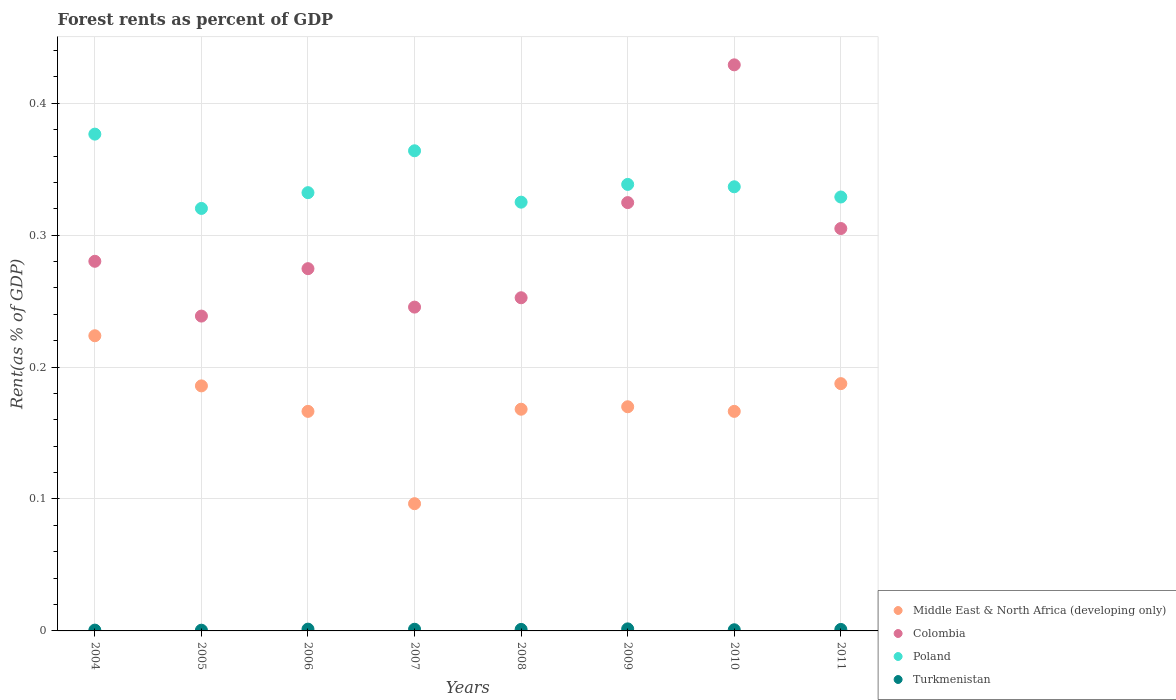What is the forest rent in Middle East & North Africa (developing only) in 2010?
Offer a very short reply. 0.17. Across all years, what is the maximum forest rent in Colombia?
Offer a very short reply. 0.43. Across all years, what is the minimum forest rent in Middle East & North Africa (developing only)?
Your answer should be compact. 0.1. In which year was the forest rent in Turkmenistan maximum?
Ensure brevity in your answer.  2009. What is the total forest rent in Colombia in the graph?
Your answer should be compact. 2.35. What is the difference between the forest rent in Colombia in 2010 and that in 2011?
Your answer should be compact. 0.12. What is the difference between the forest rent in Turkmenistan in 2008 and the forest rent in Colombia in 2007?
Your answer should be very brief. -0.24. What is the average forest rent in Turkmenistan per year?
Your answer should be very brief. 0. In the year 2007, what is the difference between the forest rent in Turkmenistan and forest rent in Poland?
Your response must be concise. -0.36. What is the ratio of the forest rent in Poland in 2005 to that in 2008?
Your response must be concise. 0.99. Is the forest rent in Turkmenistan in 2010 less than that in 2011?
Provide a short and direct response. Yes. What is the difference between the highest and the second highest forest rent in Poland?
Your answer should be very brief. 0.01. What is the difference between the highest and the lowest forest rent in Middle East & North Africa (developing only)?
Give a very brief answer. 0.13. In how many years, is the forest rent in Middle East & North Africa (developing only) greater than the average forest rent in Middle East & North Africa (developing only) taken over all years?
Make the answer very short. 3. Is the sum of the forest rent in Turkmenistan in 2007 and 2009 greater than the maximum forest rent in Poland across all years?
Give a very brief answer. No. Is it the case that in every year, the sum of the forest rent in Turkmenistan and forest rent in Colombia  is greater than the sum of forest rent in Middle East & North Africa (developing only) and forest rent in Poland?
Your answer should be compact. No. Does the forest rent in Poland monotonically increase over the years?
Provide a short and direct response. No. Is the forest rent in Colombia strictly greater than the forest rent in Middle East & North Africa (developing only) over the years?
Keep it short and to the point. Yes. How many years are there in the graph?
Provide a succinct answer. 8. Are the values on the major ticks of Y-axis written in scientific E-notation?
Provide a succinct answer. No. Does the graph contain any zero values?
Offer a very short reply. No. Does the graph contain grids?
Keep it short and to the point. Yes. Where does the legend appear in the graph?
Make the answer very short. Bottom right. How many legend labels are there?
Offer a terse response. 4. What is the title of the graph?
Keep it short and to the point. Forest rents as percent of GDP. Does "Ghana" appear as one of the legend labels in the graph?
Offer a terse response. No. What is the label or title of the Y-axis?
Make the answer very short. Rent(as % of GDP). What is the Rent(as % of GDP) of Middle East & North Africa (developing only) in 2004?
Your answer should be compact. 0.22. What is the Rent(as % of GDP) of Colombia in 2004?
Provide a short and direct response. 0.28. What is the Rent(as % of GDP) of Poland in 2004?
Offer a terse response. 0.38. What is the Rent(as % of GDP) in Turkmenistan in 2004?
Your answer should be very brief. 0. What is the Rent(as % of GDP) in Middle East & North Africa (developing only) in 2005?
Offer a terse response. 0.19. What is the Rent(as % of GDP) of Colombia in 2005?
Your answer should be compact. 0.24. What is the Rent(as % of GDP) of Poland in 2005?
Keep it short and to the point. 0.32. What is the Rent(as % of GDP) of Turkmenistan in 2005?
Provide a short and direct response. 0. What is the Rent(as % of GDP) in Middle East & North Africa (developing only) in 2006?
Offer a terse response. 0.17. What is the Rent(as % of GDP) of Colombia in 2006?
Provide a succinct answer. 0.27. What is the Rent(as % of GDP) in Poland in 2006?
Give a very brief answer. 0.33. What is the Rent(as % of GDP) in Turkmenistan in 2006?
Make the answer very short. 0. What is the Rent(as % of GDP) in Middle East & North Africa (developing only) in 2007?
Offer a very short reply. 0.1. What is the Rent(as % of GDP) in Colombia in 2007?
Make the answer very short. 0.25. What is the Rent(as % of GDP) of Poland in 2007?
Offer a very short reply. 0.36. What is the Rent(as % of GDP) in Turkmenistan in 2007?
Keep it short and to the point. 0. What is the Rent(as % of GDP) of Middle East & North Africa (developing only) in 2008?
Ensure brevity in your answer.  0.17. What is the Rent(as % of GDP) in Colombia in 2008?
Offer a terse response. 0.25. What is the Rent(as % of GDP) of Poland in 2008?
Your answer should be compact. 0.33. What is the Rent(as % of GDP) of Turkmenistan in 2008?
Ensure brevity in your answer.  0. What is the Rent(as % of GDP) of Middle East & North Africa (developing only) in 2009?
Ensure brevity in your answer.  0.17. What is the Rent(as % of GDP) of Colombia in 2009?
Provide a succinct answer. 0.32. What is the Rent(as % of GDP) of Poland in 2009?
Provide a succinct answer. 0.34. What is the Rent(as % of GDP) in Turkmenistan in 2009?
Your answer should be compact. 0. What is the Rent(as % of GDP) of Middle East & North Africa (developing only) in 2010?
Give a very brief answer. 0.17. What is the Rent(as % of GDP) of Colombia in 2010?
Your response must be concise. 0.43. What is the Rent(as % of GDP) of Poland in 2010?
Provide a short and direct response. 0.34. What is the Rent(as % of GDP) in Turkmenistan in 2010?
Give a very brief answer. 0. What is the Rent(as % of GDP) of Middle East & North Africa (developing only) in 2011?
Your response must be concise. 0.19. What is the Rent(as % of GDP) in Colombia in 2011?
Provide a short and direct response. 0.31. What is the Rent(as % of GDP) of Poland in 2011?
Ensure brevity in your answer.  0.33. What is the Rent(as % of GDP) of Turkmenistan in 2011?
Keep it short and to the point. 0. Across all years, what is the maximum Rent(as % of GDP) in Middle East & North Africa (developing only)?
Your response must be concise. 0.22. Across all years, what is the maximum Rent(as % of GDP) of Colombia?
Offer a very short reply. 0.43. Across all years, what is the maximum Rent(as % of GDP) of Poland?
Offer a terse response. 0.38. Across all years, what is the maximum Rent(as % of GDP) in Turkmenistan?
Keep it short and to the point. 0. Across all years, what is the minimum Rent(as % of GDP) in Middle East & North Africa (developing only)?
Keep it short and to the point. 0.1. Across all years, what is the minimum Rent(as % of GDP) in Colombia?
Your response must be concise. 0.24. Across all years, what is the minimum Rent(as % of GDP) of Poland?
Provide a short and direct response. 0.32. Across all years, what is the minimum Rent(as % of GDP) in Turkmenistan?
Your answer should be very brief. 0. What is the total Rent(as % of GDP) of Middle East & North Africa (developing only) in the graph?
Provide a short and direct response. 1.36. What is the total Rent(as % of GDP) in Colombia in the graph?
Your response must be concise. 2.35. What is the total Rent(as % of GDP) in Poland in the graph?
Provide a short and direct response. 2.72. What is the total Rent(as % of GDP) in Turkmenistan in the graph?
Offer a very short reply. 0.01. What is the difference between the Rent(as % of GDP) of Middle East & North Africa (developing only) in 2004 and that in 2005?
Give a very brief answer. 0.04. What is the difference between the Rent(as % of GDP) in Colombia in 2004 and that in 2005?
Provide a short and direct response. 0.04. What is the difference between the Rent(as % of GDP) of Poland in 2004 and that in 2005?
Your response must be concise. 0.06. What is the difference between the Rent(as % of GDP) in Turkmenistan in 2004 and that in 2005?
Provide a succinct answer. 0. What is the difference between the Rent(as % of GDP) of Middle East & North Africa (developing only) in 2004 and that in 2006?
Make the answer very short. 0.06. What is the difference between the Rent(as % of GDP) of Colombia in 2004 and that in 2006?
Your answer should be very brief. 0.01. What is the difference between the Rent(as % of GDP) of Poland in 2004 and that in 2006?
Offer a terse response. 0.04. What is the difference between the Rent(as % of GDP) of Turkmenistan in 2004 and that in 2006?
Keep it short and to the point. -0. What is the difference between the Rent(as % of GDP) of Middle East & North Africa (developing only) in 2004 and that in 2007?
Provide a short and direct response. 0.13. What is the difference between the Rent(as % of GDP) of Colombia in 2004 and that in 2007?
Offer a terse response. 0.03. What is the difference between the Rent(as % of GDP) of Poland in 2004 and that in 2007?
Offer a terse response. 0.01. What is the difference between the Rent(as % of GDP) in Turkmenistan in 2004 and that in 2007?
Offer a terse response. -0. What is the difference between the Rent(as % of GDP) of Middle East & North Africa (developing only) in 2004 and that in 2008?
Provide a succinct answer. 0.06. What is the difference between the Rent(as % of GDP) of Colombia in 2004 and that in 2008?
Make the answer very short. 0.03. What is the difference between the Rent(as % of GDP) of Poland in 2004 and that in 2008?
Your answer should be very brief. 0.05. What is the difference between the Rent(as % of GDP) in Turkmenistan in 2004 and that in 2008?
Your answer should be very brief. -0. What is the difference between the Rent(as % of GDP) of Middle East & North Africa (developing only) in 2004 and that in 2009?
Give a very brief answer. 0.05. What is the difference between the Rent(as % of GDP) of Colombia in 2004 and that in 2009?
Make the answer very short. -0.04. What is the difference between the Rent(as % of GDP) of Poland in 2004 and that in 2009?
Keep it short and to the point. 0.04. What is the difference between the Rent(as % of GDP) of Turkmenistan in 2004 and that in 2009?
Keep it short and to the point. -0. What is the difference between the Rent(as % of GDP) of Middle East & North Africa (developing only) in 2004 and that in 2010?
Your answer should be very brief. 0.06. What is the difference between the Rent(as % of GDP) in Colombia in 2004 and that in 2010?
Offer a very short reply. -0.15. What is the difference between the Rent(as % of GDP) in Poland in 2004 and that in 2010?
Your response must be concise. 0.04. What is the difference between the Rent(as % of GDP) of Turkmenistan in 2004 and that in 2010?
Provide a succinct answer. -0. What is the difference between the Rent(as % of GDP) in Middle East & North Africa (developing only) in 2004 and that in 2011?
Your answer should be compact. 0.04. What is the difference between the Rent(as % of GDP) of Colombia in 2004 and that in 2011?
Offer a terse response. -0.02. What is the difference between the Rent(as % of GDP) of Poland in 2004 and that in 2011?
Provide a succinct answer. 0.05. What is the difference between the Rent(as % of GDP) in Turkmenistan in 2004 and that in 2011?
Ensure brevity in your answer.  -0. What is the difference between the Rent(as % of GDP) of Middle East & North Africa (developing only) in 2005 and that in 2006?
Your answer should be very brief. 0.02. What is the difference between the Rent(as % of GDP) in Colombia in 2005 and that in 2006?
Provide a succinct answer. -0.04. What is the difference between the Rent(as % of GDP) of Poland in 2005 and that in 2006?
Your answer should be very brief. -0.01. What is the difference between the Rent(as % of GDP) in Turkmenistan in 2005 and that in 2006?
Ensure brevity in your answer.  -0. What is the difference between the Rent(as % of GDP) in Middle East & North Africa (developing only) in 2005 and that in 2007?
Ensure brevity in your answer.  0.09. What is the difference between the Rent(as % of GDP) of Colombia in 2005 and that in 2007?
Make the answer very short. -0.01. What is the difference between the Rent(as % of GDP) in Poland in 2005 and that in 2007?
Your answer should be compact. -0.04. What is the difference between the Rent(as % of GDP) of Turkmenistan in 2005 and that in 2007?
Keep it short and to the point. -0. What is the difference between the Rent(as % of GDP) in Middle East & North Africa (developing only) in 2005 and that in 2008?
Ensure brevity in your answer.  0.02. What is the difference between the Rent(as % of GDP) of Colombia in 2005 and that in 2008?
Offer a terse response. -0.01. What is the difference between the Rent(as % of GDP) of Poland in 2005 and that in 2008?
Offer a very short reply. -0. What is the difference between the Rent(as % of GDP) of Turkmenistan in 2005 and that in 2008?
Keep it short and to the point. -0. What is the difference between the Rent(as % of GDP) in Middle East & North Africa (developing only) in 2005 and that in 2009?
Ensure brevity in your answer.  0.02. What is the difference between the Rent(as % of GDP) in Colombia in 2005 and that in 2009?
Your response must be concise. -0.09. What is the difference between the Rent(as % of GDP) of Poland in 2005 and that in 2009?
Offer a very short reply. -0.02. What is the difference between the Rent(as % of GDP) in Turkmenistan in 2005 and that in 2009?
Offer a terse response. -0. What is the difference between the Rent(as % of GDP) of Middle East & North Africa (developing only) in 2005 and that in 2010?
Offer a terse response. 0.02. What is the difference between the Rent(as % of GDP) in Colombia in 2005 and that in 2010?
Offer a terse response. -0.19. What is the difference between the Rent(as % of GDP) of Poland in 2005 and that in 2010?
Keep it short and to the point. -0.02. What is the difference between the Rent(as % of GDP) of Turkmenistan in 2005 and that in 2010?
Give a very brief answer. -0. What is the difference between the Rent(as % of GDP) in Middle East & North Africa (developing only) in 2005 and that in 2011?
Provide a succinct answer. -0. What is the difference between the Rent(as % of GDP) of Colombia in 2005 and that in 2011?
Give a very brief answer. -0.07. What is the difference between the Rent(as % of GDP) in Poland in 2005 and that in 2011?
Give a very brief answer. -0.01. What is the difference between the Rent(as % of GDP) in Turkmenistan in 2005 and that in 2011?
Offer a very short reply. -0. What is the difference between the Rent(as % of GDP) in Middle East & North Africa (developing only) in 2006 and that in 2007?
Give a very brief answer. 0.07. What is the difference between the Rent(as % of GDP) of Colombia in 2006 and that in 2007?
Ensure brevity in your answer.  0.03. What is the difference between the Rent(as % of GDP) in Poland in 2006 and that in 2007?
Your answer should be very brief. -0.03. What is the difference between the Rent(as % of GDP) of Middle East & North Africa (developing only) in 2006 and that in 2008?
Offer a terse response. -0. What is the difference between the Rent(as % of GDP) in Colombia in 2006 and that in 2008?
Your response must be concise. 0.02. What is the difference between the Rent(as % of GDP) of Poland in 2006 and that in 2008?
Your response must be concise. 0.01. What is the difference between the Rent(as % of GDP) in Turkmenistan in 2006 and that in 2008?
Offer a very short reply. 0. What is the difference between the Rent(as % of GDP) in Middle East & North Africa (developing only) in 2006 and that in 2009?
Give a very brief answer. -0. What is the difference between the Rent(as % of GDP) of Colombia in 2006 and that in 2009?
Make the answer very short. -0.05. What is the difference between the Rent(as % of GDP) of Poland in 2006 and that in 2009?
Your response must be concise. -0.01. What is the difference between the Rent(as % of GDP) in Turkmenistan in 2006 and that in 2009?
Ensure brevity in your answer.  -0. What is the difference between the Rent(as % of GDP) in Middle East & North Africa (developing only) in 2006 and that in 2010?
Your answer should be compact. -0. What is the difference between the Rent(as % of GDP) in Colombia in 2006 and that in 2010?
Provide a succinct answer. -0.15. What is the difference between the Rent(as % of GDP) in Poland in 2006 and that in 2010?
Ensure brevity in your answer.  -0. What is the difference between the Rent(as % of GDP) of Turkmenistan in 2006 and that in 2010?
Provide a short and direct response. 0. What is the difference between the Rent(as % of GDP) of Middle East & North Africa (developing only) in 2006 and that in 2011?
Your response must be concise. -0.02. What is the difference between the Rent(as % of GDP) of Colombia in 2006 and that in 2011?
Ensure brevity in your answer.  -0.03. What is the difference between the Rent(as % of GDP) in Poland in 2006 and that in 2011?
Ensure brevity in your answer.  0. What is the difference between the Rent(as % of GDP) of Middle East & North Africa (developing only) in 2007 and that in 2008?
Keep it short and to the point. -0.07. What is the difference between the Rent(as % of GDP) of Colombia in 2007 and that in 2008?
Provide a short and direct response. -0.01. What is the difference between the Rent(as % of GDP) in Poland in 2007 and that in 2008?
Make the answer very short. 0.04. What is the difference between the Rent(as % of GDP) of Turkmenistan in 2007 and that in 2008?
Ensure brevity in your answer.  0. What is the difference between the Rent(as % of GDP) in Middle East & North Africa (developing only) in 2007 and that in 2009?
Offer a terse response. -0.07. What is the difference between the Rent(as % of GDP) of Colombia in 2007 and that in 2009?
Ensure brevity in your answer.  -0.08. What is the difference between the Rent(as % of GDP) of Poland in 2007 and that in 2009?
Your answer should be very brief. 0.03. What is the difference between the Rent(as % of GDP) of Turkmenistan in 2007 and that in 2009?
Your response must be concise. -0. What is the difference between the Rent(as % of GDP) of Middle East & North Africa (developing only) in 2007 and that in 2010?
Provide a short and direct response. -0.07. What is the difference between the Rent(as % of GDP) in Colombia in 2007 and that in 2010?
Make the answer very short. -0.18. What is the difference between the Rent(as % of GDP) of Poland in 2007 and that in 2010?
Your answer should be compact. 0.03. What is the difference between the Rent(as % of GDP) in Middle East & North Africa (developing only) in 2007 and that in 2011?
Make the answer very short. -0.09. What is the difference between the Rent(as % of GDP) in Colombia in 2007 and that in 2011?
Ensure brevity in your answer.  -0.06. What is the difference between the Rent(as % of GDP) in Poland in 2007 and that in 2011?
Give a very brief answer. 0.04. What is the difference between the Rent(as % of GDP) in Turkmenistan in 2007 and that in 2011?
Offer a very short reply. 0. What is the difference between the Rent(as % of GDP) in Middle East & North Africa (developing only) in 2008 and that in 2009?
Offer a terse response. -0. What is the difference between the Rent(as % of GDP) in Colombia in 2008 and that in 2009?
Ensure brevity in your answer.  -0.07. What is the difference between the Rent(as % of GDP) of Poland in 2008 and that in 2009?
Your response must be concise. -0.01. What is the difference between the Rent(as % of GDP) of Turkmenistan in 2008 and that in 2009?
Your response must be concise. -0. What is the difference between the Rent(as % of GDP) in Middle East & North Africa (developing only) in 2008 and that in 2010?
Provide a succinct answer. 0. What is the difference between the Rent(as % of GDP) in Colombia in 2008 and that in 2010?
Give a very brief answer. -0.18. What is the difference between the Rent(as % of GDP) in Poland in 2008 and that in 2010?
Make the answer very short. -0.01. What is the difference between the Rent(as % of GDP) in Turkmenistan in 2008 and that in 2010?
Keep it short and to the point. 0. What is the difference between the Rent(as % of GDP) of Middle East & North Africa (developing only) in 2008 and that in 2011?
Provide a short and direct response. -0.02. What is the difference between the Rent(as % of GDP) of Colombia in 2008 and that in 2011?
Provide a succinct answer. -0.05. What is the difference between the Rent(as % of GDP) of Poland in 2008 and that in 2011?
Make the answer very short. -0. What is the difference between the Rent(as % of GDP) of Middle East & North Africa (developing only) in 2009 and that in 2010?
Your answer should be very brief. 0. What is the difference between the Rent(as % of GDP) in Colombia in 2009 and that in 2010?
Give a very brief answer. -0.1. What is the difference between the Rent(as % of GDP) of Poland in 2009 and that in 2010?
Provide a succinct answer. 0. What is the difference between the Rent(as % of GDP) of Turkmenistan in 2009 and that in 2010?
Keep it short and to the point. 0. What is the difference between the Rent(as % of GDP) in Middle East & North Africa (developing only) in 2009 and that in 2011?
Give a very brief answer. -0.02. What is the difference between the Rent(as % of GDP) in Colombia in 2009 and that in 2011?
Ensure brevity in your answer.  0.02. What is the difference between the Rent(as % of GDP) of Poland in 2009 and that in 2011?
Make the answer very short. 0.01. What is the difference between the Rent(as % of GDP) in Turkmenistan in 2009 and that in 2011?
Your answer should be compact. 0. What is the difference between the Rent(as % of GDP) of Middle East & North Africa (developing only) in 2010 and that in 2011?
Keep it short and to the point. -0.02. What is the difference between the Rent(as % of GDP) of Colombia in 2010 and that in 2011?
Provide a short and direct response. 0.12. What is the difference between the Rent(as % of GDP) of Poland in 2010 and that in 2011?
Your response must be concise. 0.01. What is the difference between the Rent(as % of GDP) in Turkmenistan in 2010 and that in 2011?
Your answer should be very brief. -0. What is the difference between the Rent(as % of GDP) in Middle East & North Africa (developing only) in 2004 and the Rent(as % of GDP) in Colombia in 2005?
Your answer should be compact. -0.01. What is the difference between the Rent(as % of GDP) in Middle East & North Africa (developing only) in 2004 and the Rent(as % of GDP) in Poland in 2005?
Provide a succinct answer. -0.1. What is the difference between the Rent(as % of GDP) of Middle East & North Africa (developing only) in 2004 and the Rent(as % of GDP) of Turkmenistan in 2005?
Ensure brevity in your answer.  0.22. What is the difference between the Rent(as % of GDP) of Colombia in 2004 and the Rent(as % of GDP) of Poland in 2005?
Keep it short and to the point. -0.04. What is the difference between the Rent(as % of GDP) of Colombia in 2004 and the Rent(as % of GDP) of Turkmenistan in 2005?
Keep it short and to the point. 0.28. What is the difference between the Rent(as % of GDP) of Poland in 2004 and the Rent(as % of GDP) of Turkmenistan in 2005?
Keep it short and to the point. 0.38. What is the difference between the Rent(as % of GDP) of Middle East & North Africa (developing only) in 2004 and the Rent(as % of GDP) of Colombia in 2006?
Your response must be concise. -0.05. What is the difference between the Rent(as % of GDP) in Middle East & North Africa (developing only) in 2004 and the Rent(as % of GDP) in Poland in 2006?
Offer a terse response. -0.11. What is the difference between the Rent(as % of GDP) in Middle East & North Africa (developing only) in 2004 and the Rent(as % of GDP) in Turkmenistan in 2006?
Make the answer very short. 0.22. What is the difference between the Rent(as % of GDP) in Colombia in 2004 and the Rent(as % of GDP) in Poland in 2006?
Provide a short and direct response. -0.05. What is the difference between the Rent(as % of GDP) in Colombia in 2004 and the Rent(as % of GDP) in Turkmenistan in 2006?
Give a very brief answer. 0.28. What is the difference between the Rent(as % of GDP) in Poland in 2004 and the Rent(as % of GDP) in Turkmenistan in 2006?
Your response must be concise. 0.38. What is the difference between the Rent(as % of GDP) in Middle East & North Africa (developing only) in 2004 and the Rent(as % of GDP) in Colombia in 2007?
Ensure brevity in your answer.  -0.02. What is the difference between the Rent(as % of GDP) of Middle East & North Africa (developing only) in 2004 and the Rent(as % of GDP) of Poland in 2007?
Provide a short and direct response. -0.14. What is the difference between the Rent(as % of GDP) of Middle East & North Africa (developing only) in 2004 and the Rent(as % of GDP) of Turkmenistan in 2007?
Your response must be concise. 0.22. What is the difference between the Rent(as % of GDP) in Colombia in 2004 and the Rent(as % of GDP) in Poland in 2007?
Make the answer very short. -0.08. What is the difference between the Rent(as % of GDP) in Colombia in 2004 and the Rent(as % of GDP) in Turkmenistan in 2007?
Your answer should be very brief. 0.28. What is the difference between the Rent(as % of GDP) of Poland in 2004 and the Rent(as % of GDP) of Turkmenistan in 2007?
Keep it short and to the point. 0.38. What is the difference between the Rent(as % of GDP) of Middle East & North Africa (developing only) in 2004 and the Rent(as % of GDP) of Colombia in 2008?
Offer a terse response. -0.03. What is the difference between the Rent(as % of GDP) in Middle East & North Africa (developing only) in 2004 and the Rent(as % of GDP) in Poland in 2008?
Offer a very short reply. -0.1. What is the difference between the Rent(as % of GDP) of Middle East & North Africa (developing only) in 2004 and the Rent(as % of GDP) of Turkmenistan in 2008?
Your answer should be compact. 0.22. What is the difference between the Rent(as % of GDP) of Colombia in 2004 and the Rent(as % of GDP) of Poland in 2008?
Offer a terse response. -0.04. What is the difference between the Rent(as % of GDP) in Colombia in 2004 and the Rent(as % of GDP) in Turkmenistan in 2008?
Ensure brevity in your answer.  0.28. What is the difference between the Rent(as % of GDP) in Poland in 2004 and the Rent(as % of GDP) in Turkmenistan in 2008?
Your response must be concise. 0.38. What is the difference between the Rent(as % of GDP) of Middle East & North Africa (developing only) in 2004 and the Rent(as % of GDP) of Colombia in 2009?
Ensure brevity in your answer.  -0.1. What is the difference between the Rent(as % of GDP) of Middle East & North Africa (developing only) in 2004 and the Rent(as % of GDP) of Poland in 2009?
Give a very brief answer. -0.11. What is the difference between the Rent(as % of GDP) of Middle East & North Africa (developing only) in 2004 and the Rent(as % of GDP) of Turkmenistan in 2009?
Give a very brief answer. 0.22. What is the difference between the Rent(as % of GDP) of Colombia in 2004 and the Rent(as % of GDP) of Poland in 2009?
Give a very brief answer. -0.06. What is the difference between the Rent(as % of GDP) in Colombia in 2004 and the Rent(as % of GDP) in Turkmenistan in 2009?
Your response must be concise. 0.28. What is the difference between the Rent(as % of GDP) of Middle East & North Africa (developing only) in 2004 and the Rent(as % of GDP) of Colombia in 2010?
Provide a short and direct response. -0.21. What is the difference between the Rent(as % of GDP) of Middle East & North Africa (developing only) in 2004 and the Rent(as % of GDP) of Poland in 2010?
Provide a succinct answer. -0.11. What is the difference between the Rent(as % of GDP) of Middle East & North Africa (developing only) in 2004 and the Rent(as % of GDP) of Turkmenistan in 2010?
Your response must be concise. 0.22. What is the difference between the Rent(as % of GDP) of Colombia in 2004 and the Rent(as % of GDP) of Poland in 2010?
Offer a terse response. -0.06. What is the difference between the Rent(as % of GDP) of Colombia in 2004 and the Rent(as % of GDP) of Turkmenistan in 2010?
Give a very brief answer. 0.28. What is the difference between the Rent(as % of GDP) in Poland in 2004 and the Rent(as % of GDP) in Turkmenistan in 2010?
Your answer should be compact. 0.38. What is the difference between the Rent(as % of GDP) in Middle East & North Africa (developing only) in 2004 and the Rent(as % of GDP) in Colombia in 2011?
Provide a succinct answer. -0.08. What is the difference between the Rent(as % of GDP) in Middle East & North Africa (developing only) in 2004 and the Rent(as % of GDP) in Poland in 2011?
Ensure brevity in your answer.  -0.11. What is the difference between the Rent(as % of GDP) in Middle East & North Africa (developing only) in 2004 and the Rent(as % of GDP) in Turkmenistan in 2011?
Provide a short and direct response. 0.22. What is the difference between the Rent(as % of GDP) of Colombia in 2004 and the Rent(as % of GDP) of Poland in 2011?
Provide a succinct answer. -0.05. What is the difference between the Rent(as % of GDP) of Colombia in 2004 and the Rent(as % of GDP) of Turkmenistan in 2011?
Your answer should be very brief. 0.28. What is the difference between the Rent(as % of GDP) in Poland in 2004 and the Rent(as % of GDP) in Turkmenistan in 2011?
Offer a very short reply. 0.38. What is the difference between the Rent(as % of GDP) in Middle East & North Africa (developing only) in 2005 and the Rent(as % of GDP) in Colombia in 2006?
Offer a very short reply. -0.09. What is the difference between the Rent(as % of GDP) in Middle East & North Africa (developing only) in 2005 and the Rent(as % of GDP) in Poland in 2006?
Offer a terse response. -0.15. What is the difference between the Rent(as % of GDP) of Middle East & North Africa (developing only) in 2005 and the Rent(as % of GDP) of Turkmenistan in 2006?
Make the answer very short. 0.18. What is the difference between the Rent(as % of GDP) in Colombia in 2005 and the Rent(as % of GDP) in Poland in 2006?
Offer a terse response. -0.09. What is the difference between the Rent(as % of GDP) of Colombia in 2005 and the Rent(as % of GDP) of Turkmenistan in 2006?
Provide a short and direct response. 0.24. What is the difference between the Rent(as % of GDP) in Poland in 2005 and the Rent(as % of GDP) in Turkmenistan in 2006?
Make the answer very short. 0.32. What is the difference between the Rent(as % of GDP) in Middle East & North Africa (developing only) in 2005 and the Rent(as % of GDP) in Colombia in 2007?
Your response must be concise. -0.06. What is the difference between the Rent(as % of GDP) of Middle East & North Africa (developing only) in 2005 and the Rent(as % of GDP) of Poland in 2007?
Provide a short and direct response. -0.18. What is the difference between the Rent(as % of GDP) of Middle East & North Africa (developing only) in 2005 and the Rent(as % of GDP) of Turkmenistan in 2007?
Give a very brief answer. 0.18. What is the difference between the Rent(as % of GDP) in Colombia in 2005 and the Rent(as % of GDP) in Poland in 2007?
Keep it short and to the point. -0.13. What is the difference between the Rent(as % of GDP) in Colombia in 2005 and the Rent(as % of GDP) in Turkmenistan in 2007?
Provide a succinct answer. 0.24. What is the difference between the Rent(as % of GDP) in Poland in 2005 and the Rent(as % of GDP) in Turkmenistan in 2007?
Provide a short and direct response. 0.32. What is the difference between the Rent(as % of GDP) in Middle East & North Africa (developing only) in 2005 and the Rent(as % of GDP) in Colombia in 2008?
Keep it short and to the point. -0.07. What is the difference between the Rent(as % of GDP) of Middle East & North Africa (developing only) in 2005 and the Rent(as % of GDP) of Poland in 2008?
Offer a terse response. -0.14. What is the difference between the Rent(as % of GDP) of Middle East & North Africa (developing only) in 2005 and the Rent(as % of GDP) of Turkmenistan in 2008?
Provide a succinct answer. 0.18. What is the difference between the Rent(as % of GDP) in Colombia in 2005 and the Rent(as % of GDP) in Poland in 2008?
Provide a succinct answer. -0.09. What is the difference between the Rent(as % of GDP) in Colombia in 2005 and the Rent(as % of GDP) in Turkmenistan in 2008?
Provide a short and direct response. 0.24. What is the difference between the Rent(as % of GDP) in Poland in 2005 and the Rent(as % of GDP) in Turkmenistan in 2008?
Keep it short and to the point. 0.32. What is the difference between the Rent(as % of GDP) in Middle East & North Africa (developing only) in 2005 and the Rent(as % of GDP) in Colombia in 2009?
Offer a very short reply. -0.14. What is the difference between the Rent(as % of GDP) of Middle East & North Africa (developing only) in 2005 and the Rent(as % of GDP) of Poland in 2009?
Provide a succinct answer. -0.15. What is the difference between the Rent(as % of GDP) of Middle East & North Africa (developing only) in 2005 and the Rent(as % of GDP) of Turkmenistan in 2009?
Keep it short and to the point. 0.18. What is the difference between the Rent(as % of GDP) of Colombia in 2005 and the Rent(as % of GDP) of Poland in 2009?
Keep it short and to the point. -0.1. What is the difference between the Rent(as % of GDP) in Colombia in 2005 and the Rent(as % of GDP) in Turkmenistan in 2009?
Offer a terse response. 0.24. What is the difference between the Rent(as % of GDP) of Poland in 2005 and the Rent(as % of GDP) of Turkmenistan in 2009?
Ensure brevity in your answer.  0.32. What is the difference between the Rent(as % of GDP) in Middle East & North Africa (developing only) in 2005 and the Rent(as % of GDP) in Colombia in 2010?
Give a very brief answer. -0.24. What is the difference between the Rent(as % of GDP) of Middle East & North Africa (developing only) in 2005 and the Rent(as % of GDP) of Poland in 2010?
Make the answer very short. -0.15. What is the difference between the Rent(as % of GDP) of Middle East & North Africa (developing only) in 2005 and the Rent(as % of GDP) of Turkmenistan in 2010?
Give a very brief answer. 0.18. What is the difference between the Rent(as % of GDP) of Colombia in 2005 and the Rent(as % of GDP) of Poland in 2010?
Provide a succinct answer. -0.1. What is the difference between the Rent(as % of GDP) of Colombia in 2005 and the Rent(as % of GDP) of Turkmenistan in 2010?
Your answer should be compact. 0.24. What is the difference between the Rent(as % of GDP) in Poland in 2005 and the Rent(as % of GDP) in Turkmenistan in 2010?
Your response must be concise. 0.32. What is the difference between the Rent(as % of GDP) of Middle East & North Africa (developing only) in 2005 and the Rent(as % of GDP) of Colombia in 2011?
Your response must be concise. -0.12. What is the difference between the Rent(as % of GDP) in Middle East & North Africa (developing only) in 2005 and the Rent(as % of GDP) in Poland in 2011?
Give a very brief answer. -0.14. What is the difference between the Rent(as % of GDP) of Middle East & North Africa (developing only) in 2005 and the Rent(as % of GDP) of Turkmenistan in 2011?
Provide a short and direct response. 0.18. What is the difference between the Rent(as % of GDP) of Colombia in 2005 and the Rent(as % of GDP) of Poland in 2011?
Give a very brief answer. -0.09. What is the difference between the Rent(as % of GDP) in Colombia in 2005 and the Rent(as % of GDP) in Turkmenistan in 2011?
Your response must be concise. 0.24. What is the difference between the Rent(as % of GDP) in Poland in 2005 and the Rent(as % of GDP) in Turkmenistan in 2011?
Ensure brevity in your answer.  0.32. What is the difference between the Rent(as % of GDP) of Middle East & North Africa (developing only) in 2006 and the Rent(as % of GDP) of Colombia in 2007?
Ensure brevity in your answer.  -0.08. What is the difference between the Rent(as % of GDP) of Middle East & North Africa (developing only) in 2006 and the Rent(as % of GDP) of Poland in 2007?
Keep it short and to the point. -0.2. What is the difference between the Rent(as % of GDP) in Middle East & North Africa (developing only) in 2006 and the Rent(as % of GDP) in Turkmenistan in 2007?
Give a very brief answer. 0.17. What is the difference between the Rent(as % of GDP) of Colombia in 2006 and the Rent(as % of GDP) of Poland in 2007?
Offer a terse response. -0.09. What is the difference between the Rent(as % of GDP) of Colombia in 2006 and the Rent(as % of GDP) of Turkmenistan in 2007?
Make the answer very short. 0.27. What is the difference between the Rent(as % of GDP) in Poland in 2006 and the Rent(as % of GDP) in Turkmenistan in 2007?
Ensure brevity in your answer.  0.33. What is the difference between the Rent(as % of GDP) of Middle East & North Africa (developing only) in 2006 and the Rent(as % of GDP) of Colombia in 2008?
Ensure brevity in your answer.  -0.09. What is the difference between the Rent(as % of GDP) in Middle East & North Africa (developing only) in 2006 and the Rent(as % of GDP) in Poland in 2008?
Your answer should be very brief. -0.16. What is the difference between the Rent(as % of GDP) in Middle East & North Africa (developing only) in 2006 and the Rent(as % of GDP) in Turkmenistan in 2008?
Offer a very short reply. 0.17. What is the difference between the Rent(as % of GDP) in Colombia in 2006 and the Rent(as % of GDP) in Poland in 2008?
Your response must be concise. -0.05. What is the difference between the Rent(as % of GDP) of Colombia in 2006 and the Rent(as % of GDP) of Turkmenistan in 2008?
Your answer should be very brief. 0.27. What is the difference between the Rent(as % of GDP) in Poland in 2006 and the Rent(as % of GDP) in Turkmenistan in 2008?
Provide a succinct answer. 0.33. What is the difference between the Rent(as % of GDP) of Middle East & North Africa (developing only) in 2006 and the Rent(as % of GDP) of Colombia in 2009?
Your answer should be very brief. -0.16. What is the difference between the Rent(as % of GDP) of Middle East & North Africa (developing only) in 2006 and the Rent(as % of GDP) of Poland in 2009?
Make the answer very short. -0.17. What is the difference between the Rent(as % of GDP) of Middle East & North Africa (developing only) in 2006 and the Rent(as % of GDP) of Turkmenistan in 2009?
Provide a succinct answer. 0.16. What is the difference between the Rent(as % of GDP) of Colombia in 2006 and the Rent(as % of GDP) of Poland in 2009?
Offer a terse response. -0.06. What is the difference between the Rent(as % of GDP) in Colombia in 2006 and the Rent(as % of GDP) in Turkmenistan in 2009?
Your answer should be very brief. 0.27. What is the difference between the Rent(as % of GDP) of Poland in 2006 and the Rent(as % of GDP) of Turkmenistan in 2009?
Offer a terse response. 0.33. What is the difference between the Rent(as % of GDP) of Middle East & North Africa (developing only) in 2006 and the Rent(as % of GDP) of Colombia in 2010?
Your response must be concise. -0.26. What is the difference between the Rent(as % of GDP) in Middle East & North Africa (developing only) in 2006 and the Rent(as % of GDP) in Poland in 2010?
Your response must be concise. -0.17. What is the difference between the Rent(as % of GDP) of Middle East & North Africa (developing only) in 2006 and the Rent(as % of GDP) of Turkmenistan in 2010?
Your response must be concise. 0.17. What is the difference between the Rent(as % of GDP) of Colombia in 2006 and the Rent(as % of GDP) of Poland in 2010?
Your answer should be compact. -0.06. What is the difference between the Rent(as % of GDP) in Colombia in 2006 and the Rent(as % of GDP) in Turkmenistan in 2010?
Keep it short and to the point. 0.27. What is the difference between the Rent(as % of GDP) of Poland in 2006 and the Rent(as % of GDP) of Turkmenistan in 2010?
Keep it short and to the point. 0.33. What is the difference between the Rent(as % of GDP) in Middle East & North Africa (developing only) in 2006 and the Rent(as % of GDP) in Colombia in 2011?
Ensure brevity in your answer.  -0.14. What is the difference between the Rent(as % of GDP) in Middle East & North Africa (developing only) in 2006 and the Rent(as % of GDP) in Poland in 2011?
Your answer should be very brief. -0.16. What is the difference between the Rent(as % of GDP) in Middle East & North Africa (developing only) in 2006 and the Rent(as % of GDP) in Turkmenistan in 2011?
Keep it short and to the point. 0.17. What is the difference between the Rent(as % of GDP) in Colombia in 2006 and the Rent(as % of GDP) in Poland in 2011?
Offer a terse response. -0.05. What is the difference between the Rent(as % of GDP) of Colombia in 2006 and the Rent(as % of GDP) of Turkmenistan in 2011?
Give a very brief answer. 0.27. What is the difference between the Rent(as % of GDP) in Poland in 2006 and the Rent(as % of GDP) in Turkmenistan in 2011?
Your response must be concise. 0.33. What is the difference between the Rent(as % of GDP) of Middle East & North Africa (developing only) in 2007 and the Rent(as % of GDP) of Colombia in 2008?
Your response must be concise. -0.16. What is the difference between the Rent(as % of GDP) in Middle East & North Africa (developing only) in 2007 and the Rent(as % of GDP) in Poland in 2008?
Offer a terse response. -0.23. What is the difference between the Rent(as % of GDP) of Middle East & North Africa (developing only) in 2007 and the Rent(as % of GDP) of Turkmenistan in 2008?
Provide a succinct answer. 0.1. What is the difference between the Rent(as % of GDP) of Colombia in 2007 and the Rent(as % of GDP) of Poland in 2008?
Your response must be concise. -0.08. What is the difference between the Rent(as % of GDP) of Colombia in 2007 and the Rent(as % of GDP) of Turkmenistan in 2008?
Offer a very short reply. 0.24. What is the difference between the Rent(as % of GDP) of Poland in 2007 and the Rent(as % of GDP) of Turkmenistan in 2008?
Offer a very short reply. 0.36. What is the difference between the Rent(as % of GDP) in Middle East & North Africa (developing only) in 2007 and the Rent(as % of GDP) in Colombia in 2009?
Provide a short and direct response. -0.23. What is the difference between the Rent(as % of GDP) of Middle East & North Africa (developing only) in 2007 and the Rent(as % of GDP) of Poland in 2009?
Your answer should be very brief. -0.24. What is the difference between the Rent(as % of GDP) in Middle East & North Africa (developing only) in 2007 and the Rent(as % of GDP) in Turkmenistan in 2009?
Offer a very short reply. 0.09. What is the difference between the Rent(as % of GDP) in Colombia in 2007 and the Rent(as % of GDP) in Poland in 2009?
Your response must be concise. -0.09. What is the difference between the Rent(as % of GDP) of Colombia in 2007 and the Rent(as % of GDP) of Turkmenistan in 2009?
Your response must be concise. 0.24. What is the difference between the Rent(as % of GDP) in Poland in 2007 and the Rent(as % of GDP) in Turkmenistan in 2009?
Give a very brief answer. 0.36. What is the difference between the Rent(as % of GDP) of Middle East & North Africa (developing only) in 2007 and the Rent(as % of GDP) of Colombia in 2010?
Keep it short and to the point. -0.33. What is the difference between the Rent(as % of GDP) in Middle East & North Africa (developing only) in 2007 and the Rent(as % of GDP) in Poland in 2010?
Give a very brief answer. -0.24. What is the difference between the Rent(as % of GDP) of Middle East & North Africa (developing only) in 2007 and the Rent(as % of GDP) of Turkmenistan in 2010?
Make the answer very short. 0.1. What is the difference between the Rent(as % of GDP) of Colombia in 2007 and the Rent(as % of GDP) of Poland in 2010?
Give a very brief answer. -0.09. What is the difference between the Rent(as % of GDP) of Colombia in 2007 and the Rent(as % of GDP) of Turkmenistan in 2010?
Keep it short and to the point. 0.24. What is the difference between the Rent(as % of GDP) of Poland in 2007 and the Rent(as % of GDP) of Turkmenistan in 2010?
Ensure brevity in your answer.  0.36. What is the difference between the Rent(as % of GDP) of Middle East & North Africa (developing only) in 2007 and the Rent(as % of GDP) of Colombia in 2011?
Offer a terse response. -0.21. What is the difference between the Rent(as % of GDP) in Middle East & North Africa (developing only) in 2007 and the Rent(as % of GDP) in Poland in 2011?
Make the answer very short. -0.23. What is the difference between the Rent(as % of GDP) in Middle East & North Africa (developing only) in 2007 and the Rent(as % of GDP) in Turkmenistan in 2011?
Provide a short and direct response. 0.1. What is the difference between the Rent(as % of GDP) of Colombia in 2007 and the Rent(as % of GDP) of Poland in 2011?
Offer a very short reply. -0.08. What is the difference between the Rent(as % of GDP) of Colombia in 2007 and the Rent(as % of GDP) of Turkmenistan in 2011?
Your answer should be very brief. 0.24. What is the difference between the Rent(as % of GDP) of Poland in 2007 and the Rent(as % of GDP) of Turkmenistan in 2011?
Provide a succinct answer. 0.36. What is the difference between the Rent(as % of GDP) of Middle East & North Africa (developing only) in 2008 and the Rent(as % of GDP) of Colombia in 2009?
Your answer should be very brief. -0.16. What is the difference between the Rent(as % of GDP) in Middle East & North Africa (developing only) in 2008 and the Rent(as % of GDP) in Poland in 2009?
Your answer should be very brief. -0.17. What is the difference between the Rent(as % of GDP) in Middle East & North Africa (developing only) in 2008 and the Rent(as % of GDP) in Turkmenistan in 2009?
Give a very brief answer. 0.17. What is the difference between the Rent(as % of GDP) in Colombia in 2008 and the Rent(as % of GDP) in Poland in 2009?
Make the answer very short. -0.09. What is the difference between the Rent(as % of GDP) of Colombia in 2008 and the Rent(as % of GDP) of Turkmenistan in 2009?
Give a very brief answer. 0.25. What is the difference between the Rent(as % of GDP) of Poland in 2008 and the Rent(as % of GDP) of Turkmenistan in 2009?
Make the answer very short. 0.32. What is the difference between the Rent(as % of GDP) in Middle East & North Africa (developing only) in 2008 and the Rent(as % of GDP) in Colombia in 2010?
Ensure brevity in your answer.  -0.26. What is the difference between the Rent(as % of GDP) of Middle East & North Africa (developing only) in 2008 and the Rent(as % of GDP) of Poland in 2010?
Your answer should be very brief. -0.17. What is the difference between the Rent(as % of GDP) in Middle East & North Africa (developing only) in 2008 and the Rent(as % of GDP) in Turkmenistan in 2010?
Ensure brevity in your answer.  0.17. What is the difference between the Rent(as % of GDP) in Colombia in 2008 and the Rent(as % of GDP) in Poland in 2010?
Offer a very short reply. -0.08. What is the difference between the Rent(as % of GDP) in Colombia in 2008 and the Rent(as % of GDP) in Turkmenistan in 2010?
Your answer should be very brief. 0.25. What is the difference between the Rent(as % of GDP) in Poland in 2008 and the Rent(as % of GDP) in Turkmenistan in 2010?
Keep it short and to the point. 0.32. What is the difference between the Rent(as % of GDP) of Middle East & North Africa (developing only) in 2008 and the Rent(as % of GDP) of Colombia in 2011?
Your answer should be compact. -0.14. What is the difference between the Rent(as % of GDP) of Middle East & North Africa (developing only) in 2008 and the Rent(as % of GDP) of Poland in 2011?
Offer a very short reply. -0.16. What is the difference between the Rent(as % of GDP) in Middle East & North Africa (developing only) in 2008 and the Rent(as % of GDP) in Turkmenistan in 2011?
Provide a short and direct response. 0.17. What is the difference between the Rent(as % of GDP) in Colombia in 2008 and the Rent(as % of GDP) in Poland in 2011?
Offer a very short reply. -0.08. What is the difference between the Rent(as % of GDP) in Colombia in 2008 and the Rent(as % of GDP) in Turkmenistan in 2011?
Keep it short and to the point. 0.25. What is the difference between the Rent(as % of GDP) of Poland in 2008 and the Rent(as % of GDP) of Turkmenistan in 2011?
Your answer should be compact. 0.32. What is the difference between the Rent(as % of GDP) in Middle East & North Africa (developing only) in 2009 and the Rent(as % of GDP) in Colombia in 2010?
Your answer should be compact. -0.26. What is the difference between the Rent(as % of GDP) in Middle East & North Africa (developing only) in 2009 and the Rent(as % of GDP) in Poland in 2010?
Offer a terse response. -0.17. What is the difference between the Rent(as % of GDP) in Middle East & North Africa (developing only) in 2009 and the Rent(as % of GDP) in Turkmenistan in 2010?
Keep it short and to the point. 0.17. What is the difference between the Rent(as % of GDP) in Colombia in 2009 and the Rent(as % of GDP) in Poland in 2010?
Offer a terse response. -0.01. What is the difference between the Rent(as % of GDP) of Colombia in 2009 and the Rent(as % of GDP) of Turkmenistan in 2010?
Keep it short and to the point. 0.32. What is the difference between the Rent(as % of GDP) of Poland in 2009 and the Rent(as % of GDP) of Turkmenistan in 2010?
Offer a terse response. 0.34. What is the difference between the Rent(as % of GDP) of Middle East & North Africa (developing only) in 2009 and the Rent(as % of GDP) of Colombia in 2011?
Your answer should be very brief. -0.14. What is the difference between the Rent(as % of GDP) in Middle East & North Africa (developing only) in 2009 and the Rent(as % of GDP) in Poland in 2011?
Make the answer very short. -0.16. What is the difference between the Rent(as % of GDP) of Middle East & North Africa (developing only) in 2009 and the Rent(as % of GDP) of Turkmenistan in 2011?
Your answer should be very brief. 0.17. What is the difference between the Rent(as % of GDP) in Colombia in 2009 and the Rent(as % of GDP) in Poland in 2011?
Keep it short and to the point. -0. What is the difference between the Rent(as % of GDP) in Colombia in 2009 and the Rent(as % of GDP) in Turkmenistan in 2011?
Provide a short and direct response. 0.32. What is the difference between the Rent(as % of GDP) in Poland in 2009 and the Rent(as % of GDP) in Turkmenistan in 2011?
Your response must be concise. 0.34. What is the difference between the Rent(as % of GDP) of Middle East & North Africa (developing only) in 2010 and the Rent(as % of GDP) of Colombia in 2011?
Your answer should be compact. -0.14. What is the difference between the Rent(as % of GDP) in Middle East & North Africa (developing only) in 2010 and the Rent(as % of GDP) in Poland in 2011?
Keep it short and to the point. -0.16. What is the difference between the Rent(as % of GDP) in Middle East & North Africa (developing only) in 2010 and the Rent(as % of GDP) in Turkmenistan in 2011?
Keep it short and to the point. 0.17. What is the difference between the Rent(as % of GDP) of Colombia in 2010 and the Rent(as % of GDP) of Poland in 2011?
Offer a terse response. 0.1. What is the difference between the Rent(as % of GDP) in Colombia in 2010 and the Rent(as % of GDP) in Turkmenistan in 2011?
Provide a short and direct response. 0.43. What is the difference between the Rent(as % of GDP) in Poland in 2010 and the Rent(as % of GDP) in Turkmenistan in 2011?
Provide a succinct answer. 0.34. What is the average Rent(as % of GDP) in Middle East & North Africa (developing only) per year?
Ensure brevity in your answer.  0.17. What is the average Rent(as % of GDP) in Colombia per year?
Your answer should be compact. 0.29. What is the average Rent(as % of GDP) in Poland per year?
Ensure brevity in your answer.  0.34. What is the average Rent(as % of GDP) of Turkmenistan per year?
Your response must be concise. 0. In the year 2004, what is the difference between the Rent(as % of GDP) in Middle East & North Africa (developing only) and Rent(as % of GDP) in Colombia?
Your answer should be very brief. -0.06. In the year 2004, what is the difference between the Rent(as % of GDP) of Middle East & North Africa (developing only) and Rent(as % of GDP) of Poland?
Offer a terse response. -0.15. In the year 2004, what is the difference between the Rent(as % of GDP) of Middle East & North Africa (developing only) and Rent(as % of GDP) of Turkmenistan?
Give a very brief answer. 0.22. In the year 2004, what is the difference between the Rent(as % of GDP) of Colombia and Rent(as % of GDP) of Poland?
Offer a terse response. -0.1. In the year 2004, what is the difference between the Rent(as % of GDP) of Colombia and Rent(as % of GDP) of Turkmenistan?
Offer a terse response. 0.28. In the year 2004, what is the difference between the Rent(as % of GDP) in Poland and Rent(as % of GDP) in Turkmenistan?
Give a very brief answer. 0.38. In the year 2005, what is the difference between the Rent(as % of GDP) of Middle East & North Africa (developing only) and Rent(as % of GDP) of Colombia?
Make the answer very short. -0.05. In the year 2005, what is the difference between the Rent(as % of GDP) of Middle East & North Africa (developing only) and Rent(as % of GDP) of Poland?
Your response must be concise. -0.13. In the year 2005, what is the difference between the Rent(as % of GDP) in Middle East & North Africa (developing only) and Rent(as % of GDP) in Turkmenistan?
Give a very brief answer. 0.19. In the year 2005, what is the difference between the Rent(as % of GDP) in Colombia and Rent(as % of GDP) in Poland?
Your answer should be compact. -0.08. In the year 2005, what is the difference between the Rent(as % of GDP) in Colombia and Rent(as % of GDP) in Turkmenistan?
Offer a very short reply. 0.24. In the year 2005, what is the difference between the Rent(as % of GDP) in Poland and Rent(as % of GDP) in Turkmenistan?
Provide a succinct answer. 0.32. In the year 2006, what is the difference between the Rent(as % of GDP) in Middle East & North Africa (developing only) and Rent(as % of GDP) in Colombia?
Ensure brevity in your answer.  -0.11. In the year 2006, what is the difference between the Rent(as % of GDP) in Middle East & North Africa (developing only) and Rent(as % of GDP) in Poland?
Your response must be concise. -0.17. In the year 2006, what is the difference between the Rent(as % of GDP) of Middle East & North Africa (developing only) and Rent(as % of GDP) of Turkmenistan?
Ensure brevity in your answer.  0.17. In the year 2006, what is the difference between the Rent(as % of GDP) in Colombia and Rent(as % of GDP) in Poland?
Ensure brevity in your answer.  -0.06. In the year 2006, what is the difference between the Rent(as % of GDP) of Colombia and Rent(as % of GDP) of Turkmenistan?
Make the answer very short. 0.27. In the year 2006, what is the difference between the Rent(as % of GDP) of Poland and Rent(as % of GDP) of Turkmenistan?
Your response must be concise. 0.33. In the year 2007, what is the difference between the Rent(as % of GDP) of Middle East & North Africa (developing only) and Rent(as % of GDP) of Colombia?
Make the answer very short. -0.15. In the year 2007, what is the difference between the Rent(as % of GDP) of Middle East & North Africa (developing only) and Rent(as % of GDP) of Poland?
Provide a short and direct response. -0.27. In the year 2007, what is the difference between the Rent(as % of GDP) of Middle East & North Africa (developing only) and Rent(as % of GDP) of Turkmenistan?
Your response must be concise. 0.1. In the year 2007, what is the difference between the Rent(as % of GDP) in Colombia and Rent(as % of GDP) in Poland?
Provide a short and direct response. -0.12. In the year 2007, what is the difference between the Rent(as % of GDP) of Colombia and Rent(as % of GDP) of Turkmenistan?
Provide a succinct answer. 0.24. In the year 2007, what is the difference between the Rent(as % of GDP) of Poland and Rent(as % of GDP) of Turkmenistan?
Provide a short and direct response. 0.36. In the year 2008, what is the difference between the Rent(as % of GDP) in Middle East & North Africa (developing only) and Rent(as % of GDP) in Colombia?
Offer a terse response. -0.08. In the year 2008, what is the difference between the Rent(as % of GDP) of Middle East & North Africa (developing only) and Rent(as % of GDP) of Poland?
Offer a terse response. -0.16. In the year 2008, what is the difference between the Rent(as % of GDP) of Middle East & North Africa (developing only) and Rent(as % of GDP) of Turkmenistan?
Your answer should be compact. 0.17. In the year 2008, what is the difference between the Rent(as % of GDP) of Colombia and Rent(as % of GDP) of Poland?
Keep it short and to the point. -0.07. In the year 2008, what is the difference between the Rent(as % of GDP) in Colombia and Rent(as % of GDP) in Turkmenistan?
Keep it short and to the point. 0.25. In the year 2008, what is the difference between the Rent(as % of GDP) of Poland and Rent(as % of GDP) of Turkmenistan?
Ensure brevity in your answer.  0.32. In the year 2009, what is the difference between the Rent(as % of GDP) in Middle East & North Africa (developing only) and Rent(as % of GDP) in Colombia?
Ensure brevity in your answer.  -0.15. In the year 2009, what is the difference between the Rent(as % of GDP) in Middle East & North Africa (developing only) and Rent(as % of GDP) in Poland?
Offer a terse response. -0.17. In the year 2009, what is the difference between the Rent(as % of GDP) in Middle East & North Africa (developing only) and Rent(as % of GDP) in Turkmenistan?
Offer a terse response. 0.17. In the year 2009, what is the difference between the Rent(as % of GDP) in Colombia and Rent(as % of GDP) in Poland?
Keep it short and to the point. -0.01. In the year 2009, what is the difference between the Rent(as % of GDP) of Colombia and Rent(as % of GDP) of Turkmenistan?
Offer a terse response. 0.32. In the year 2009, what is the difference between the Rent(as % of GDP) in Poland and Rent(as % of GDP) in Turkmenistan?
Provide a short and direct response. 0.34. In the year 2010, what is the difference between the Rent(as % of GDP) of Middle East & North Africa (developing only) and Rent(as % of GDP) of Colombia?
Provide a succinct answer. -0.26. In the year 2010, what is the difference between the Rent(as % of GDP) in Middle East & North Africa (developing only) and Rent(as % of GDP) in Poland?
Your response must be concise. -0.17. In the year 2010, what is the difference between the Rent(as % of GDP) in Middle East & North Africa (developing only) and Rent(as % of GDP) in Turkmenistan?
Provide a short and direct response. 0.17. In the year 2010, what is the difference between the Rent(as % of GDP) of Colombia and Rent(as % of GDP) of Poland?
Keep it short and to the point. 0.09. In the year 2010, what is the difference between the Rent(as % of GDP) of Colombia and Rent(as % of GDP) of Turkmenistan?
Ensure brevity in your answer.  0.43. In the year 2010, what is the difference between the Rent(as % of GDP) in Poland and Rent(as % of GDP) in Turkmenistan?
Offer a very short reply. 0.34. In the year 2011, what is the difference between the Rent(as % of GDP) of Middle East & North Africa (developing only) and Rent(as % of GDP) of Colombia?
Give a very brief answer. -0.12. In the year 2011, what is the difference between the Rent(as % of GDP) in Middle East & North Africa (developing only) and Rent(as % of GDP) in Poland?
Keep it short and to the point. -0.14. In the year 2011, what is the difference between the Rent(as % of GDP) of Middle East & North Africa (developing only) and Rent(as % of GDP) of Turkmenistan?
Ensure brevity in your answer.  0.19. In the year 2011, what is the difference between the Rent(as % of GDP) of Colombia and Rent(as % of GDP) of Poland?
Provide a short and direct response. -0.02. In the year 2011, what is the difference between the Rent(as % of GDP) in Colombia and Rent(as % of GDP) in Turkmenistan?
Your response must be concise. 0.3. In the year 2011, what is the difference between the Rent(as % of GDP) in Poland and Rent(as % of GDP) in Turkmenistan?
Provide a succinct answer. 0.33. What is the ratio of the Rent(as % of GDP) in Middle East & North Africa (developing only) in 2004 to that in 2005?
Ensure brevity in your answer.  1.2. What is the ratio of the Rent(as % of GDP) in Colombia in 2004 to that in 2005?
Provide a succinct answer. 1.17. What is the ratio of the Rent(as % of GDP) in Poland in 2004 to that in 2005?
Provide a succinct answer. 1.18. What is the ratio of the Rent(as % of GDP) of Turkmenistan in 2004 to that in 2005?
Your response must be concise. 1.12. What is the ratio of the Rent(as % of GDP) of Middle East & North Africa (developing only) in 2004 to that in 2006?
Make the answer very short. 1.34. What is the ratio of the Rent(as % of GDP) of Colombia in 2004 to that in 2006?
Provide a succinct answer. 1.02. What is the ratio of the Rent(as % of GDP) in Poland in 2004 to that in 2006?
Ensure brevity in your answer.  1.13. What is the ratio of the Rent(as % of GDP) of Turkmenistan in 2004 to that in 2006?
Ensure brevity in your answer.  0.45. What is the ratio of the Rent(as % of GDP) of Middle East & North Africa (developing only) in 2004 to that in 2007?
Offer a terse response. 2.32. What is the ratio of the Rent(as % of GDP) of Colombia in 2004 to that in 2007?
Make the answer very short. 1.14. What is the ratio of the Rent(as % of GDP) in Poland in 2004 to that in 2007?
Your answer should be compact. 1.03. What is the ratio of the Rent(as % of GDP) in Turkmenistan in 2004 to that in 2007?
Make the answer very short. 0.48. What is the ratio of the Rent(as % of GDP) in Middle East & North Africa (developing only) in 2004 to that in 2008?
Your answer should be very brief. 1.33. What is the ratio of the Rent(as % of GDP) in Colombia in 2004 to that in 2008?
Ensure brevity in your answer.  1.11. What is the ratio of the Rent(as % of GDP) of Poland in 2004 to that in 2008?
Offer a very short reply. 1.16. What is the ratio of the Rent(as % of GDP) of Turkmenistan in 2004 to that in 2008?
Provide a short and direct response. 0.54. What is the ratio of the Rent(as % of GDP) of Middle East & North Africa (developing only) in 2004 to that in 2009?
Offer a very short reply. 1.32. What is the ratio of the Rent(as % of GDP) in Colombia in 2004 to that in 2009?
Offer a very short reply. 0.86. What is the ratio of the Rent(as % of GDP) of Poland in 2004 to that in 2009?
Your answer should be compact. 1.11. What is the ratio of the Rent(as % of GDP) of Turkmenistan in 2004 to that in 2009?
Make the answer very short. 0.4. What is the ratio of the Rent(as % of GDP) in Middle East & North Africa (developing only) in 2004 to that in 2010?
Provide a short and direct response. 1.34. What is the ratio of the Rent(as % of GDP) of Colombia in 2004 to that in 2010?
Provide a short and direct response. 0.65. What is the ratio of the Rent(as % of GDP) of Poland in 2004 to that in 2010?
Your response must be concise. 1.12. What is the ratio of the Rent(as % of GDP) of Turkmenistan in 2004 to that in 2010?
Offer a very short reply. 0.71. What is the ratio of the Rent(as % of GDP) of Middle East & North Africa (developing only) in 2004 to that in 2011?
Your answer should be very brief. 1.19. What is the ratio of the Rent(as % of GDP) in Colombia in 2004 to that in 2011?
Provide a short and direct response. 0.92. What is the ratio of the Rent(as % of GDP) in Poland in 2004 to that in 2011?
Offer a terse response. 1.14. What is the ratio of the Rent(as % of GDP) of Turkmenistan in 2004 to that in 2011?
Your answer should be compact. 0.55. What is the ratio of the Rent(as % of GDP) of Middle East & North Africa (developing only) in 2005 to that in 2006?
Offer a terse response. 1.12. What is the ratio of the Rent(as % of GDP) in Colombia in 2005 to that in 2006?
Provide a short and direct response. 0.87. What is the ratio of the Rent(as % of GDP) in Turkmenistan in 2005 to that in 2006?
Your answer should be compact. 0.4. What is the ratio of the Rent(as % of GDP) of Middle East & North Africa (developing only) in 2005 to that in 2007?
Make the answer very short. 1.93. What is the ratio of the Rent(as % of GDP) in Colombia in 2005 to that in 2007?
Provide a succinct answer. 0.97. What is the ratio of the Rent(as % of GDP) of Poland in 2005 to that in 2007?
Give a very brief answer. 0.88. What is the ratio of the Rent(as % of GDP) in Turkmenistan in 2005 to that in 2007?
Provide a short and direct response. 0.43. What is the ratio of the Rent(as % of GDP) of Middle East & North Africa (developing only) in 2005 to that in 2008?
Give a very brief answer. 1.11. What is the ratio of the Rent(as % of GDP) of Colombia in 2005 to that in 2008?
Make the answer very short. 0.94. What is the ratio of the Rent(as % of GDP) of Poland in 2005 to that in 2008?
Offer a very short reply. 0.99. What is the ratio of the Rent(as % of GDP) in Turkmenistan in 2005 to that in 2008?
Ensure brevity in your answer.  0.48. What is the ratio of the Rent(as % of GDP) of Middle East & North Africa (developing only) in 2005 to that in 2009?
Keep it short and to the point. 1.09. What is the ratio of the Rent(as % of GDP) in Colombia in 2005 to that in 2009?
Offer a terse response. 0.74. What is the ratio of the Rent(as % of GDP) of Poland in 2005 to that in 2009?
Your answer should be very brief. 0.95. What is the ratio of the Rent(as % of GDP) in Turkmenistan in 2005 to that in 2009?
Your answer should be compact. 0.35. What is the ratio of the Rent(as % of GDP) in Middle East & North Africa (developing only) in 2005 to that in 2010?
Keep it short and to the point. 1.12. What is the ratio of the Rent(as % of GDP) of Colombia in 2005 to that in 2010?
Make the answer very short. 0.56. What is the ratio of the Rent(as % of GDP) in Poland in 2005 to that in 2010?
Provide a short and direct response. 0.95. What is the ratio of the Rent(as % of GDP) of Turkmenistan in 2005 to that in 2010?
Provide a short and direct response. 0.63. What is the ratio of the Rent(as % of GDP) of Middle East & North Africa (developing only) in 2005 to that in 2011?
Make the answer very short. 0.99. What is the ratio of the Rent(as % of GDP) of Colombia in 2005 to that in 2011?
Offer a very short reply. 0.78. What is the ratio of the Rent(as % of GDP) of Poland in 2005 to that in 2011?
Make the answer very short. 0.97. What is the ratio of the Rent(as % of GDP) of Turkmenistan in 2005 to that in 2011?
Provide a succinct answer. 0.49. What is the ratio of the Rent(as % of GDP) in Middle East & North Africa (developing only) in 2006 to that in 2007?
Give a very brief answer. 1.73. What is the ratio of the Rent(as % of GDP) of Colombia in 2006 to that in 2007?
Your answer should be compact. 1.12. What is the ratio of the Rent(as % of GDP) of Poland in 2006 to that in 2007?
Offer a very short reply. 0.91. What is the ratio of the Rent(as % of GDP) in Turkmenistan in 2006 to that in 2007?
Your answer should be very brief. 1.07. What is the ratio of the Rent(as % of GDP) of Middle East & North Africa (developing only) in 2006 to that in 2008?
Give a very brief answer. 0.99. What is the ratio of the Rent(as % of GDP) in Colombia in 2006 to that in 2008?
Your response must be concise. 1.09. What is the ratio of the Rent(as % of GDP) of Poland in 2006 to that in 2008?
Your response must be concise. 1.02. What is the ratio of the Rent(as % of GDP) of Turkmenistan in 2006 to that in 2008?
Provide a succinct answer. 1.19. What is the ratio of the Rent(as % of GDP) in Middle East & North Africa (developing only) in 2006 to that in 2009?
Make the answer very short. 0.98. What is the ratio of the Rent(as % of GDP) of Colombia in 2006 to that in 2009?
Make the answer very short. 0.85. What is the ratio of the Rent(as % of GDP) of Poland in 2006 to that in 2009?
Your answer should be very brief. 0.98. What is the ratio of the Rent(as % of GDP) of Turkmenistan in 2006 to that in 2009?
Ensure brevity in your answer.  0.88. What is the ratio of the Rent(as % of GDP) in Middle East & North Africa (developing only) in 2006 to that in 2010?
Your answer should be very brief. 1. What is the ratio of the Rent(as % of GDP) of Colombia in 2006 to that in 2010?
Your answer should be very brief. 0.64. What is the ratio of the Rent(as % of GDP) in Poland in 2006 to that in 2010?
Provide a succinct answer. 0.99. What is the ratio of the Rent(as % of GDP) in Turkmenistan in 2006 to that in 2010?
Ensure brevity in your answer.  1.56. What is the ratio of the Rent(as % of GDP) of Middle East & North Africa (developing only) in 2006 to that in 2011?
Ensure brevity in your answer.  0.89. What is the ratio of the Rent(as % of GDP) of Colombia in 2006 to that in 2011?
Provide a succinct answer. 0.9. What is the ratio of the Rent(as % of GDP) of Turkmenistan in 2006 to that in 2011?
Keep it short and to the point. 1.21. What is the ratio of the Rent(as % of GDP) of Middle East & North Africa (developing only) in 2007 to that in 2008?
Keep it short and to the point. 0.57. What is the ratio of the Rent(as % of GDP) of Colombia in 2007 to that in 2008?
Provide a succinct answer. 0.97. What is the ratio of the Rent(as % of GDP) of Poland in 2007 to that in 2008?
Provide a succinct answer. 1.12. What is the ratio of the Rent(as % of GDP) in Turkmenistan in 2007 to that in 2008?
Your response must be concise. 1.11. What is the ratio of the Rent(as % of GDP) of Middle East & North Africa (developing only) in 2007 to that in 2009?
Provide a succinct answer. 0.57. What is the ratio of the Rent(as % of GDP) of Colombia in 2007 to that in 2009?
Your answer should be compact. 0.76. What is the ratio of the Rent(as % of GDP) of Poland in 2007 to that in 2009?
Your answer should be very brief. 1.08. What is the ratio of the Rent(as % of GDP) of Turkmenistan in 2007 to that in 2009?
Provide a succinct answer. 0.82. What is the ratio of the Rent(as % of GDP) of Middle East & North Africa (developing only) in 2007 to that in 2010?
Ensure brevity in your answer.  0.58. What is the ratio of the Rent(as % of GDP) of Colombia in 2007 to that in 2010?
Ensure brevity in your answer.  0.57. What is the ratio of the Rent(as % of GDP) of Poland in 2007 to that in 2010?
Keep it short and to the point. 1.08. What is the ratio of the Rent(as % of GDP) in Turkmenistan in 2007 to that in 2010?
Keep it short and to the point. 1.46. What is the ratio of the Rent(as % of GDP) in Middle East & North Africa (developing only) in 2007 to that in 2011?
Offer a very short reply. 0.51. What is the ratio of the Rent(as % of GDP) in Colombia in 2007 to that in 2011?
Your response must be concise. 0.8. What is the ratio of the Rent(as % of GDP) of Poland in 2007 to that in 2011?
Keep it short and to the point. 1.11. What is the ratio of the Rent(as % of GDP) in Turkmenistan in 2007 to that in 2011?
Give a very brief answer. 1.14. What is the ratio of the Rent(as % of GDP) in Colombia in 2008 to that in 2009?
Provide a succinct answer. 0.78. What is the ratio of the Rent(as % of GDP) in Poland in 2008 to that in 2009?
Your response must be concise. 0.96. What is the ratio of the Rent(as % of GDP) of Turkmenistan in 2008 to that in 2009?
Provide a short and direct response. 0.74. What is the ratio of the Rent(as % of GDP) of Middle East & North Africa (developing only) in 2008 to that in 2010?
Ensure brevity in your answer.  1.01. What is the ratio of the Rent(as % of GDP) of Colombia in 2008 to that in 2010?
Offer a very short reply. 0.59. What is the ratio of the Rent(as % of GDP) of Poland in 2008 to that in 2010?
Ensure brevity in your answer.  0.97. What is the ratio of the Rent(as % of GDP) of Turkmenistan in 2008 to that in 2010?
Provide a succinct answer. 1.31. What is the ratio of the Rent(as % of GDP) in Middle East & North Africa (developing only) in 2008 to that in 2011?
Your response must be concise. 0.9. What is the ratio of the Rent(as % of GDP) of Colombia in 2008 to that in 2011?
Ensure brevity in your answer.  0.83. What is the ratio of the Rent(as % of GDP) in Turkmenistan in 2008 to that in 2011?
Keep it short and to the point. 1.02. What is the ratio of the Rent(as % of GDP) of Middle East & North Africa (developing only) in 2009 to that in 2010?
Your answer should be very brief. 1.02. What is the ratio of the Rent(as % of GDP) in Colombia in 2009 to that in 2010?
Provide a short and direct response. 0.76. What is the ratio of the Rent(as % of GDP) in Turkmenistan in 2009 to that in 2010?
Offer a terse response. 1.78. What is the ratio of the Rent(as % of GDP) of Middle East & North Africa (developing only) in 2009 to that in 2011?
Offer a very short reply. 0.91. What is the ratio of the Rent(as % of GDP) of Colombia in 2009 to that in 2011?
Provide a short and direct response. 1.06. What is the ratio of the Rent(as % of GDP) of Turkmenistan in 2009 to that in 2011?
Provide a short and direct response. 1.38. What is the ratio of the Rent(as % of GDP) of Middle East & North Africa (developing only) in 2010 to that in 2011?
Offer a very short reply. 0.89. What is the ratio of the Rent(as % of GDP) of Colombia in 2010 to that in 2011?
Your answer should be compact. 1.41. What is the ratio of the Rent(as % of GDP) of Poland in 2010 to that in 2011?
Ensure brevity in your answer.  1.02. What is the ratio of the Rent(as % of GDP) in Turkmenistan in 2010 to that in 2011?
Ensure brevity in your answer.  0.78. What is the difference between the highest and the second highest Rent(as % of GDP) of Middle East & North Africa (developing only)?
Offer a terse response. 0.04. What is the difference between the highest and the second highest Rent(as % of GDP) in Colombia?
Ensure brevity in your answer.  0.1. What is the difference between the highest and the second highest Rent(as % of GDP) of Poland?
Offer a terse response. 0.01. What is the difference between the highest and the lowest Rent(as % of GDP) of Middle East & North Africa (developing only)?
Provide a succinct answer. 0.13. What is the difference between the highest and the lowest Rent(as % of GDP) in Colombia?
Provide a succinct answer. 0.19. What is the difference between the highest and the lowest Rent(as % of GDP) in Poland?
Offer a very short reply. 0.06. 